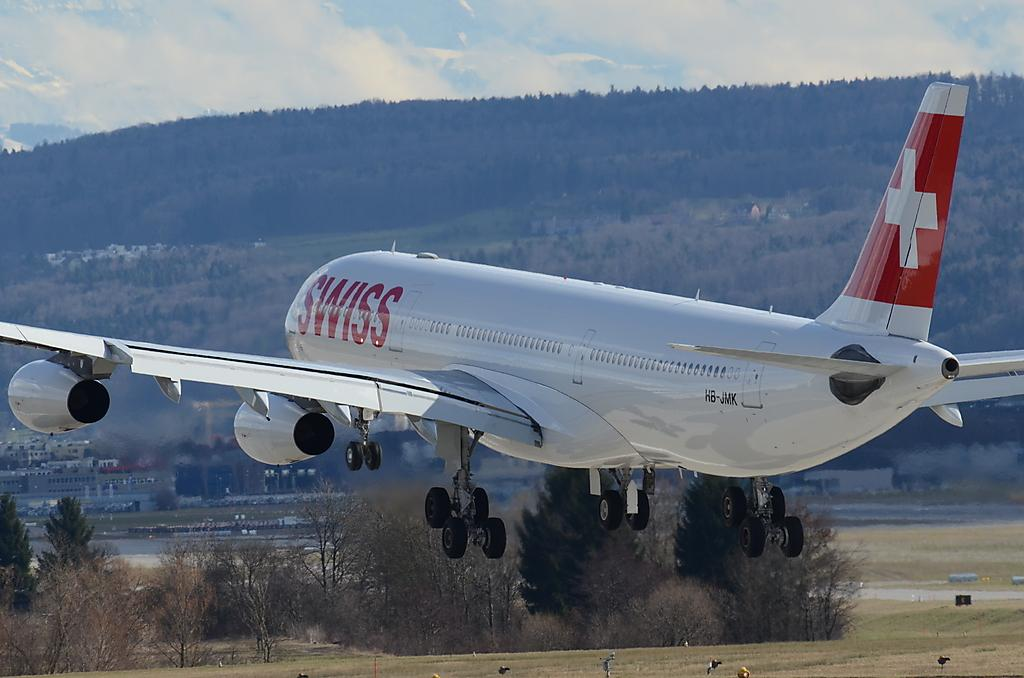What is the main subject of the image? The main subject of the image is an airplane. Can you describe the colors of the airplane? The airplane is white and red in color. What type of natural environment can be seen in the image? There is grass, trees, and a mountain visible in the image. What type of structures can be seen in the image? There are buildings in the image. What is the condition of the sky in the image? The sky is cloudy in the image. What animals can be seen on the grass? Birds are present on the grass. What flavor of beds can be seen in the image? There are no beds present in the image, and therefore no flavor can be associated with them. 